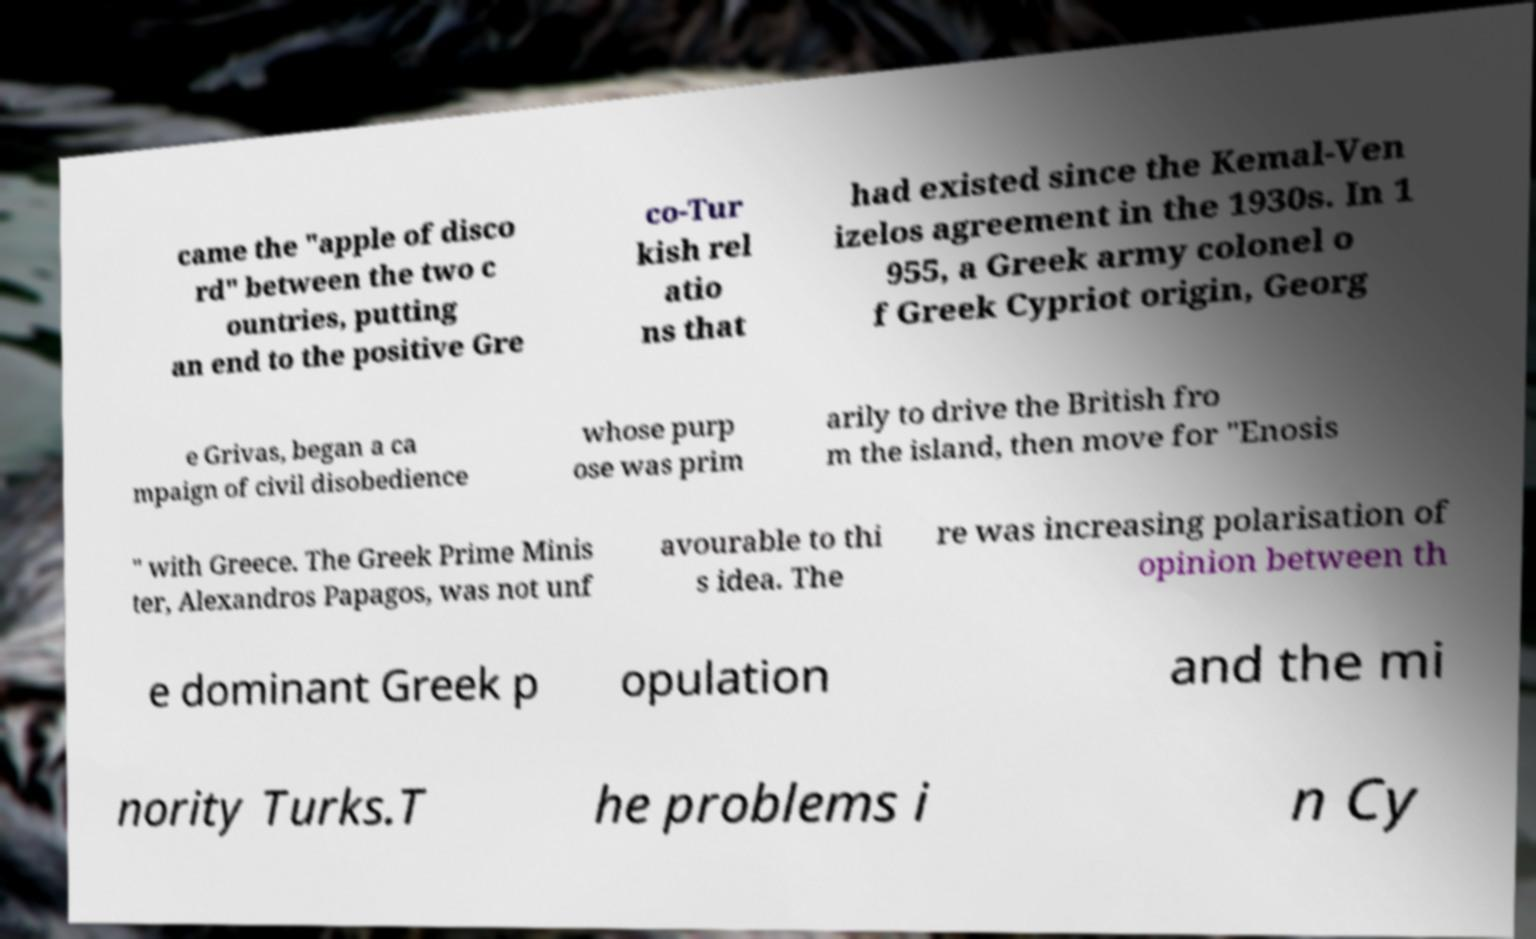Could you extract and type out the text from this image? came the "apple of disco rd" between the two c ountries, putting an end to the positive Gre co-Tur kish rel atio ns that had existed since the Kemal-Ven izelos agreement in the 1930s. In 1 955, a Greek army colonel o f Greek Cypriot origin, Georg e Grivas, began a ca mpaign of civil disobedience whose purp ose was prim arily to drive the British fro m the island, then move for "Enosis " with Greece. The Greek Prime Minis ter, Alexandros Papagos, was not unf avourable to thi s idea. The re was increasing polarisation of opinion between th e dominant Greek p opulation and the mi nority Turks.T he problems i n Cy 